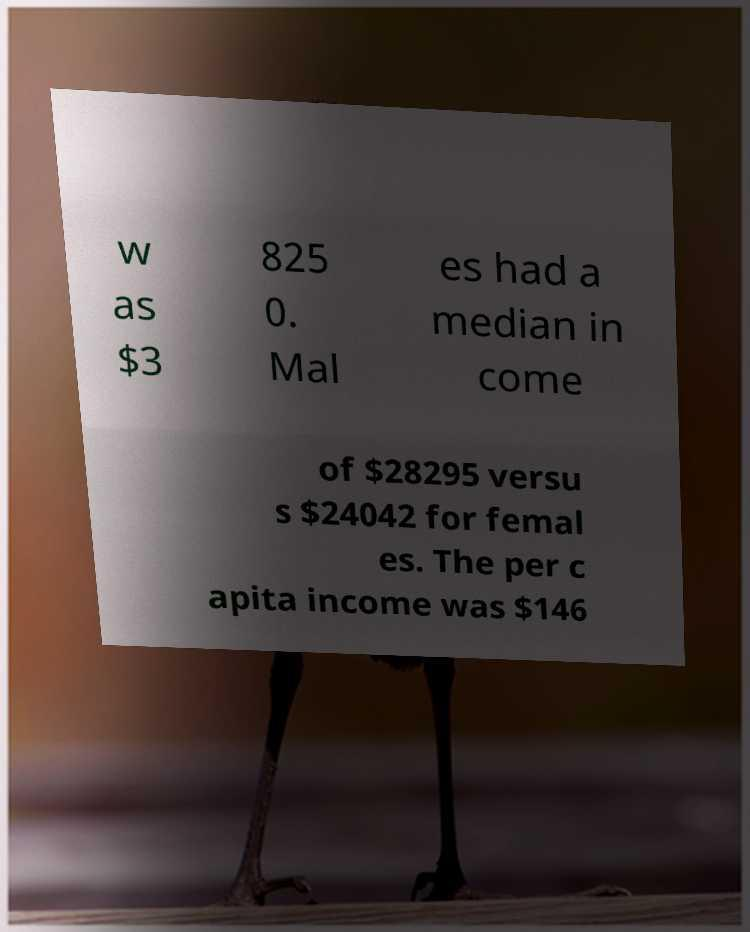Could you extract and type out the text from this image? w as $3 825 0. Mal es had a median in come of $28295 versu s $24042 for femal es. The per c apita income was $146 